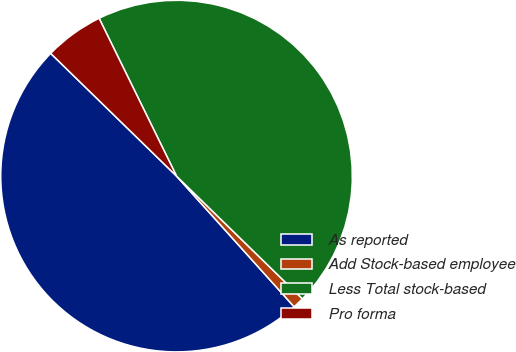<chart> <loc_0><loc_0><loc_500><loc_500><pie_chart><fcel>As reported<fcel>Add Stock-based employee<fcel>Less Total stock-based<fcel>Pro forma<nl><fcel>48.96%<fcel>1.04%<fcel>44.56%<fcel>5.44%<nl></chart> 